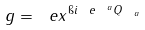Convert formula to latex. <formula><loc_0><loc_0><loc_500><loc_500>g = \ e x ^ { \i i \ e ^ { \ a } Q _ { \ a } }</formula> 